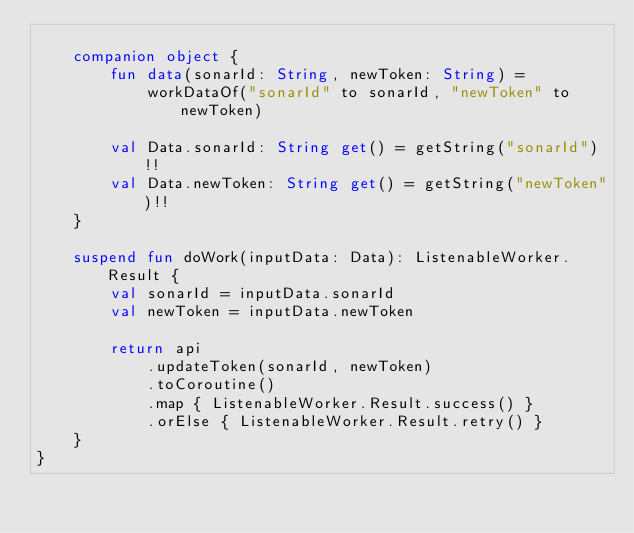<code> <loc_0><loc_0><loc_500><loc_500><_Kotlin_>
    companion object {
        fun data(sonarId: String, newToken: String) =
            workDataOf("sonarId" to sonarId, "newToken" to newToken)

        val Data.sonarId: String get() = getString("sonarId")!!
        val Data.newToken: String get() = getString("newToken")!!
    }

    suspend fun doWork(inputData: Data): ListenableWorker.Result {
        val sonarId = inputData.sonarId
        val newToken = inputData.newToken

        return api
            .updateToken(sonarId, newToken)
            .toCoroutine()
            .map { ListenableWorker.Result.success() }
            .orElse { ListenableWorker.Result.retry() }
    }
}
</code> 